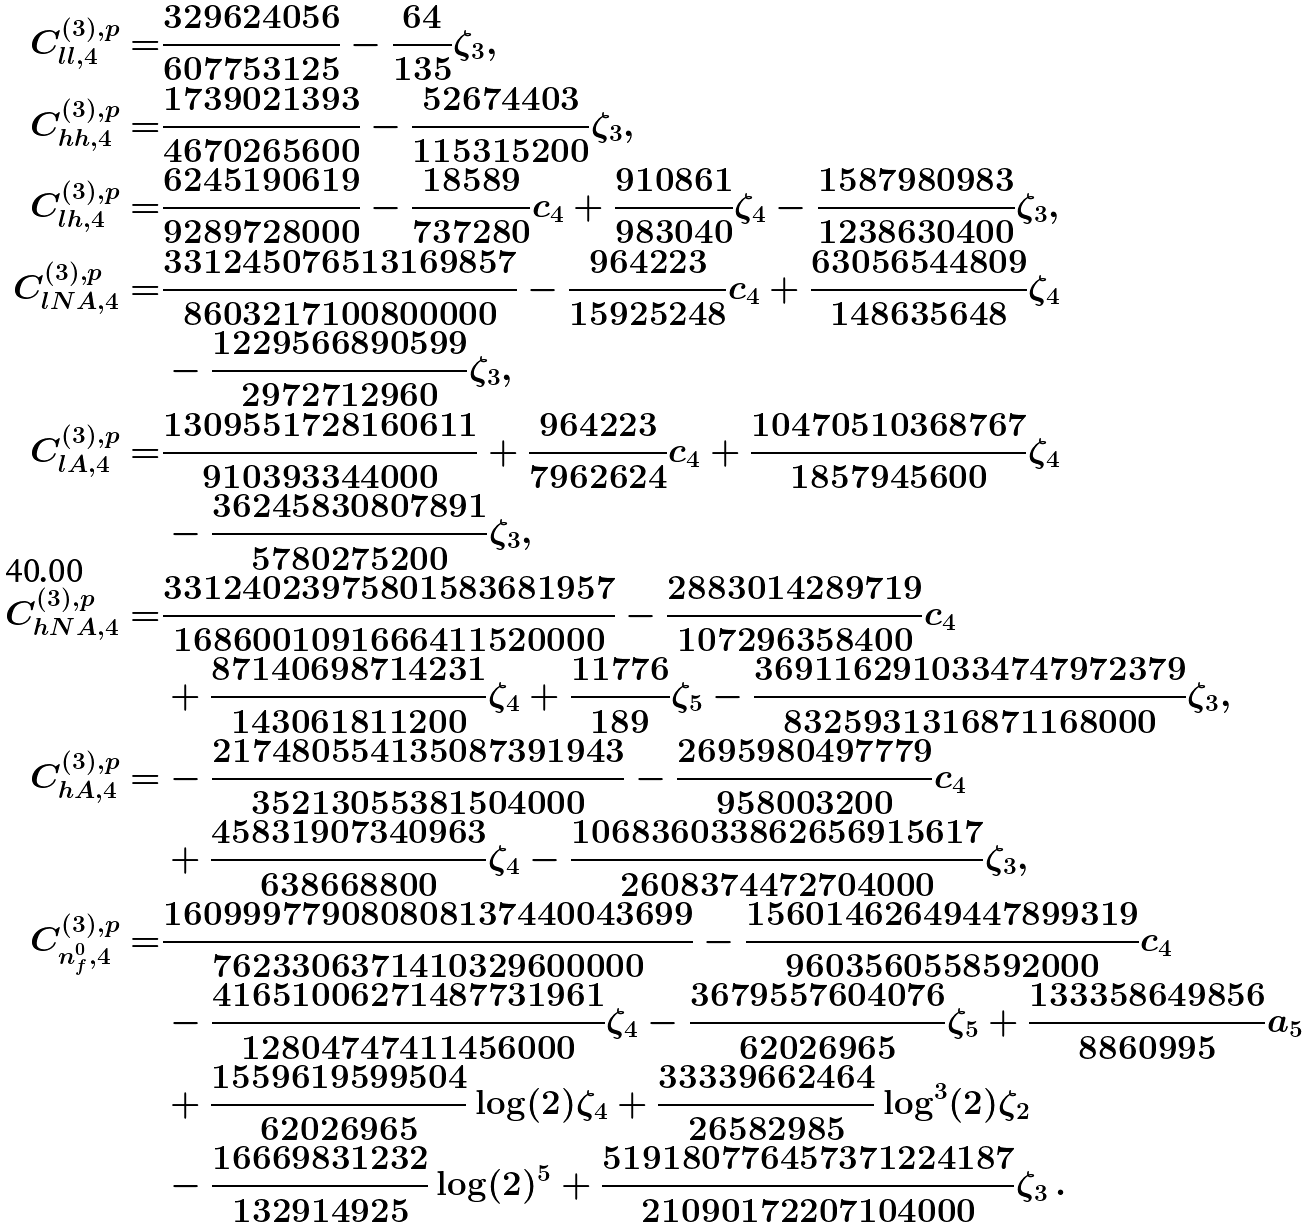<formula> <loc_0><loc_0><loc_500><loc_500>C ^ { ( 3 ) , p } _ { l l , 4 } = & \frac { 3 2 9 6 2 4 0 5 6 } { 6 0 7 7 5 3 1 2 5 } - \frac { 6 4 } { 1 3 5 } \zeta _ { 3 } , \\ C ^ { ( 3 ) , p } _ { h h , 4 } = & \frac { 1 7 3 9 0 2 1 3 9 3 } { 4 6 7 0 2 6 5 6 0 0 } - \frac { 5 2 6 7 4 4 0 3 } { 1 1 5 3 1 5 2 0 0 } \zeta _ { 3 } , \\ C ^ { ( 3 ) , p } _ { l h , 4 } = & \frac { 6 2 4 5 1 9 0 6 1 9 } { 9 2 8 9 7 2 8 0 0 0 } - \frac { 1 8 5 8 9 } { 7 3 7 2 8 0 } c _ { 4 } + \frac { 9 1 0 8 6 1 } { 9 8 3 0 4 0 } \zeta _ { 4 } - \frac { 1 5 8 7 9 8 0 9 8 3 } { 1 2 3 8 6 3 0 4 0 0 } \zeta _ { 3 } , \\ C ^ { ( 3 ) , p } _ { l N A , 4 } = & \frac { 3 3 1 2 4 5 0 7 6 5 1 3 1 6 9 8 5 7 } { 8 6 0 3 2 1 7 1 0 0 8 0 0 0 0 0 } - \frac { 9 6 4 2 2 3 } { 1 5 9 2 5 2 4 8 } c _ { 4 } + \frac { 6 3 0 5 6 5 4 4 8 0 9 } { 1 4 8 6 3 5 6 4 8 } \zeta _ { 4 } \\ & - \frac { 1 2 2 9 5 6 6 8 9 0 5 9 9 } { 2 9 7 2 7 1 2 9 6 0 } \zeta _ { 3 } , \\ C ^ { ( 3 ) , p } _ { l A , 4 } = & \frac { 1 3 0 9 5 5 1 7 2 8 1 6 0 6 1 1 } { 9 1 0 3 9 3 3 4 4 0 0 0 } + \frac { 9 6 4 2 2 3 } { 7 9 6 2 6 2 4 } c _ { 4 } + \frac { 1 0 4 7 0 5 1 0 3 6 8 7 6 7 } { 1 8 5 7 9 4 5 6 0 0 } \zeta _ { 4 } \\ & - \frac { 3 6 2 4 5 8 3 0 8 0 7 8 9 1 } { 5 7 8 0 2 7 5 2 0 0 } \zeta _ { 3 } , \\ C ^ { ( 3 ) , p } _ { h N A , 4 } = & \frac { 3 3 1 2 4 0 2 3 9 7 5 8 0 1 5 8 3 6 8 1 9 5 7 } { 1 6 8 6 0 0 1 0 9 1 6 6 6 4 1 1 5 2 0 0 0 0 } - \frac { 2 8 8 3 0 1 4 2 8 9 7 1 9 } { 1 0 7 2 9 6 3 5 8 4 0 0 } c _ { 4 } \\ & + \frac { 8 7 1 4 0 6 9 8 7 1 4 2 3 1 } { 1 4 3 0 6 1 8 1 1 2 0 0 } \zeta _ { 4 } + \frac { 1 1 7 7 6 } { 1 8 9 } \zeta _ { 5 } - \frac { 3 6 9 1 1 6 2 9 1 0 3 3 4 7 4 7 9 7 2 3 7 9 } { 8 3 2 5 9 3 1 3 1 6 8 7 1 1 6 8 0 0 0 } \zeta _ { 3 } , \\ C ^ { ( 3 ) , p } _ { h A , 4 } = & - \frac { 2 1 7 4 8 0 5 5 4 1 3 5 0 8 7 3 9 1 9 4 3 } { 3 5 2 1 3 0 5 5 3 8 1 5 0 4 0 0 0 } - \frac { 2 6 9 5 9 8 0 4 9 7 7 7 9 } { 9 5 8 0 0 3 2 0 0 } c _ { 4 } \\ & + \frac { 4 5 8 3 1 9 0 7 3 4 0 9 6 3 } { 6 3 8 6 6 8 8 0 0 } \zeta _ { 4 } - \frac { 1 0 6 8 3 6 0 3 3 8 6 2 6 5 6 9 1 5 6 1 7 } { 2 6 0 8 3 7 4 4 7 2 7 0 4 0 0 0 } \zeta _ { 3 } , \\ C ^ { ( 3 ) , p } _ { n _ { f } ^ { 0 } , 4 } = & \frac { 1 6 0 9 9 9 7 7 9 0 8 0 8 0 8 1 3 7 4 4 0 0 4 3 6 9 9 } { 7 6 2 3 3 0 6 3 7 1 4 1 0 3 2 9 6 0 0 0 0 0 } - \frac { 1 5 6 0 1 4 6 2 6 4 9 4 4 7 8 9 9 3 1 9 } { 9 6 0 3 5 6 0 5 5 8 5 9 2 0 0 0 } c _ { 4 } \\ & - \frac { 4 1 6 5 1 0 0 6 2 7 1 4 8 7 7 3 1 9 6 1 } { 1 2 8 0 4 7 4 7 4 1 1 4 5 6 0 0 0 } \zeta _ { 4 } - \frac { 3 6 7 9 5 5 7 6 0 4 0 7 6 } { 6 2 0 2 6 9 6 5 } \zeta _ { 5 } + \frac { 1 3 3 3 5 8 6 4 9 8 5 6 } { 8 8 6 0 9 9 5 } a _ { 5 } \\ & + \frac { 1 5 5 9 6 1 9 5 9 9 5 0 4 } { 6 2 0 2 6 9 6 5 } \log ( 2 ) \zeta _ { 4 } + \frac { 3 3 3 3 9 6 6 2 4 6 4 } { 2 6 5 8 2 9 8 5 } \log ^ { 3 } ( 2 ) \zeta _ { 2 } \\ & - \frac { 1 6 6 6 9 8 3 1 2 3 2 } { 1 3 2 9 1 4 9 2 5 } \log ( 2 ) ^ { 5 } + \frac { 5 1 9 1 8 0 7 7 6 4 5 7 3 7 1 2 2 4 1 8 7 } { 2 1 0 9 0 1 7 2 2 0 7 1 0 4 0 0 0 } \zeta _ { 3 } \, .</formula> 